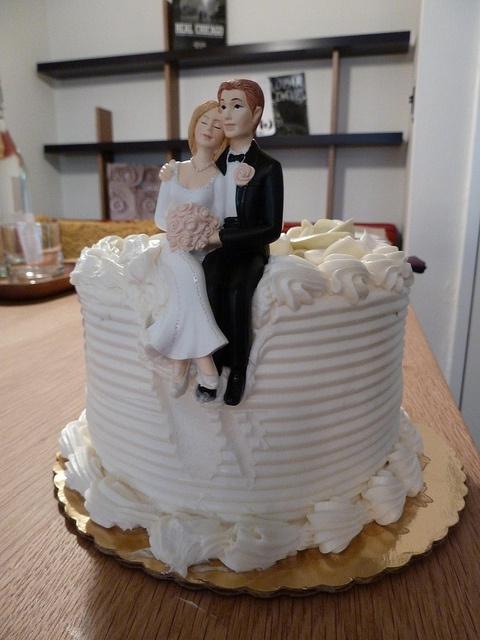Describe the objects in this image and their specific colors. I can see dining table in gray, darkgray, black, and maroon tones, cake in gray and darkgray tones, people in gray and darkgray tones, book in gray and black tones, and bottle in gray and darkgray tones in this image. 